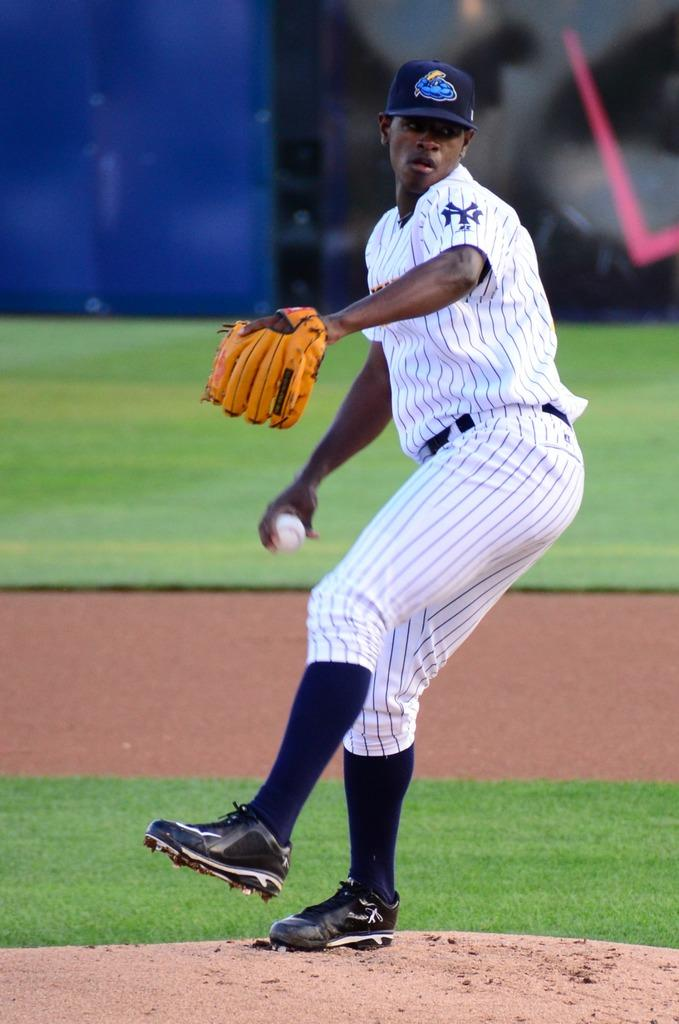<image>
Summarize the visual content of the image. a man with NY on his baseball jersey 